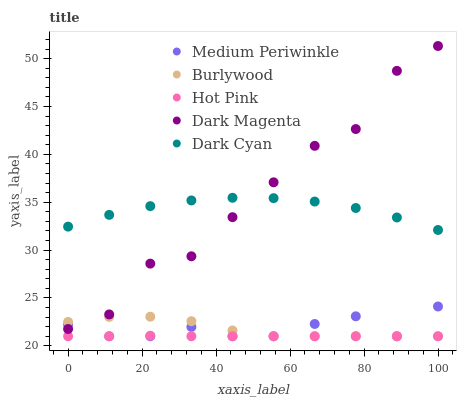Does Hot Pink have the minimum area under the curve?
Answer yes or no. Yes. Does Dark Magenta have the maximum area under the curve?
Answer yes or no. Yes. Does Dark Cyan have the minimum area under the curve?
Answer yes or no. No. Does Dark Cyan have the maximum area under the curve?
Answer yes or no. No. Is Hot Pink the smoothest?
Answer yes or no. Yes. Is Dark Magenta the roughest?
Answer yes or no. Yes. Is Dark Cyan the smoothest?
Answer yes or no. No. Is Dark Cyan the roughest?
Answer yes or no. No. Does Burlywood have the lowest value?
Answer yes or no. Yes. Does Dark Cyan have the lowest value?
Answer yes or no. No. Does Dark Magenta have the highest value?
Answer yes or no. Yes. Does Dark Cyan have the highest value?
Answer yes or no. No. Is Burlywood less than Dark Cyan?
Answer yes or no. Yes. Is Dark Cyan greater than Hot Pink?
Answer yes or no. Yes. Does Dark Magenta intersect Burlywood?
Answer yes or no. Yes. Is Dark Magenta less than Burlywood?
Answer yes or no. No. Is Dark Magenta greater than Burlywood?
Answer yes or no. No. Does Burlywood intersect Dark Cyan?
Answer yes or no. No. 